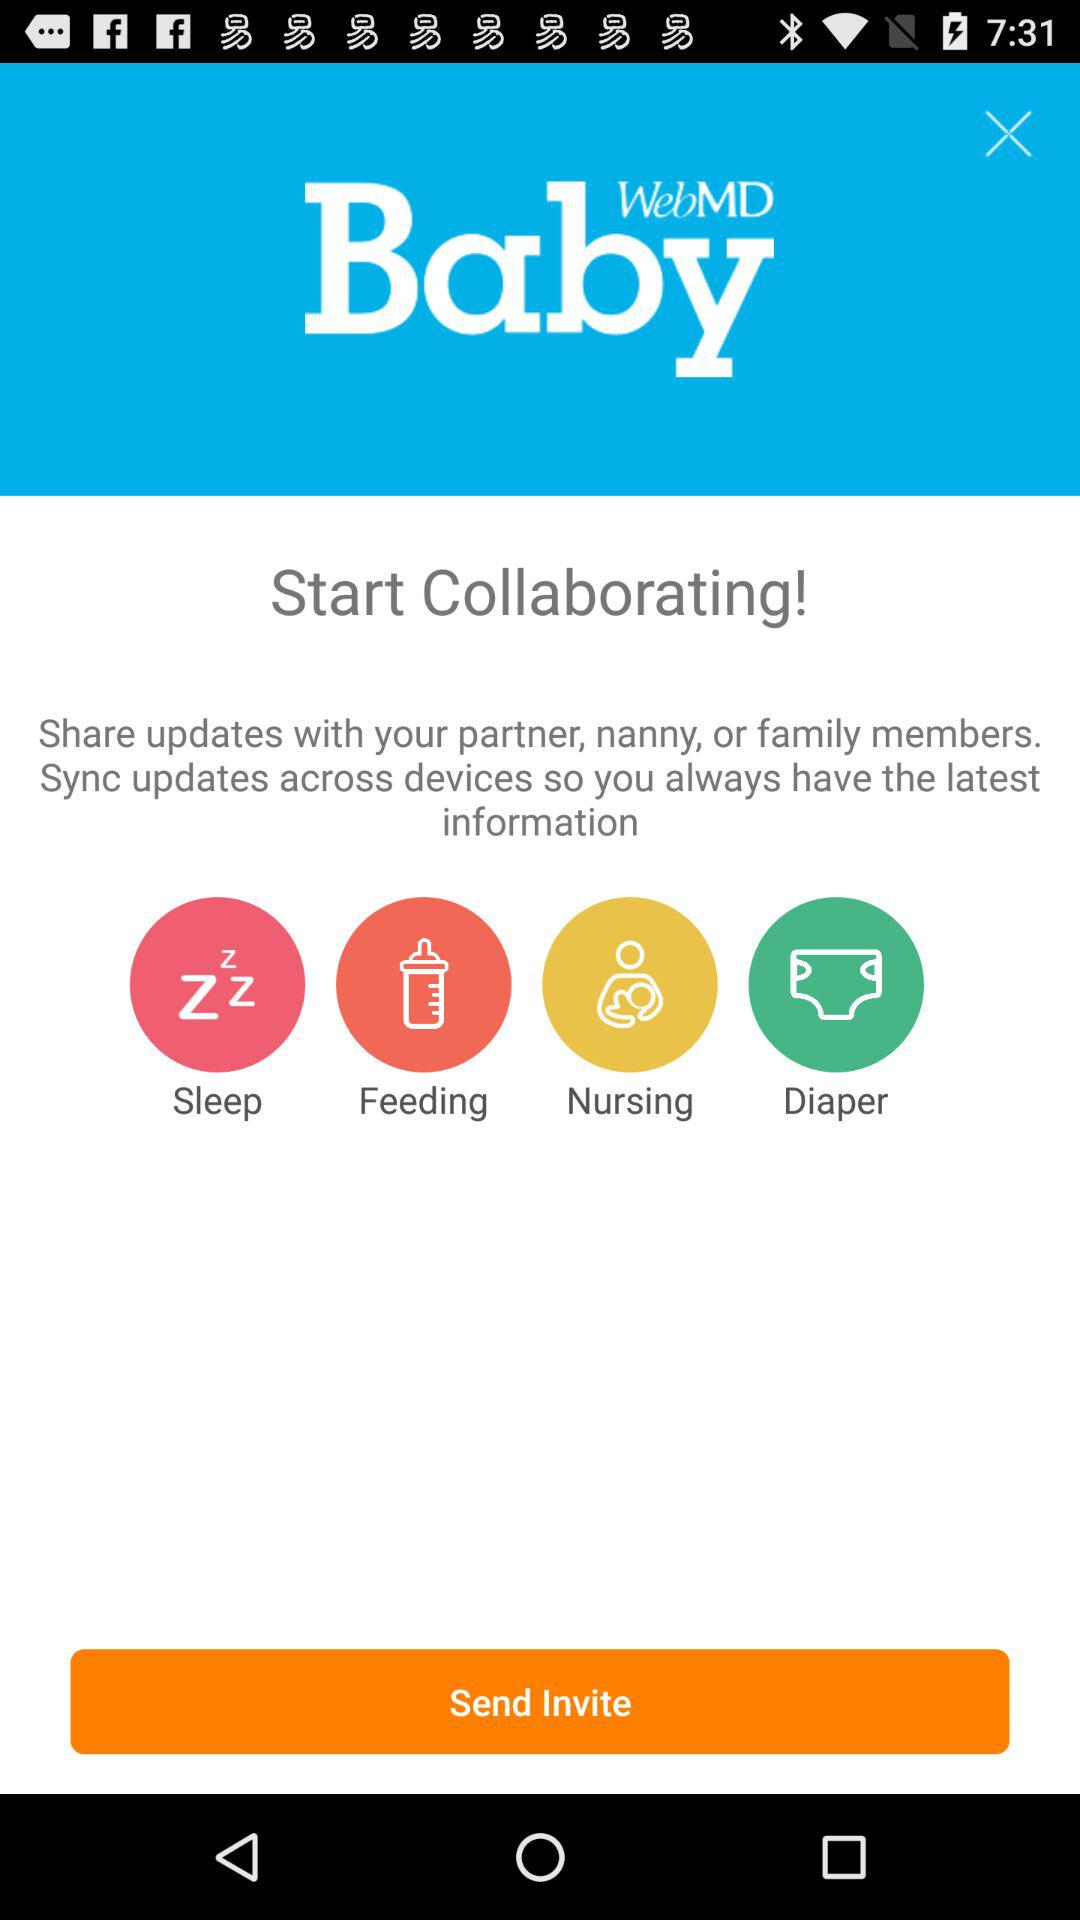What is the application name? The application name is "WebMD Baby". 